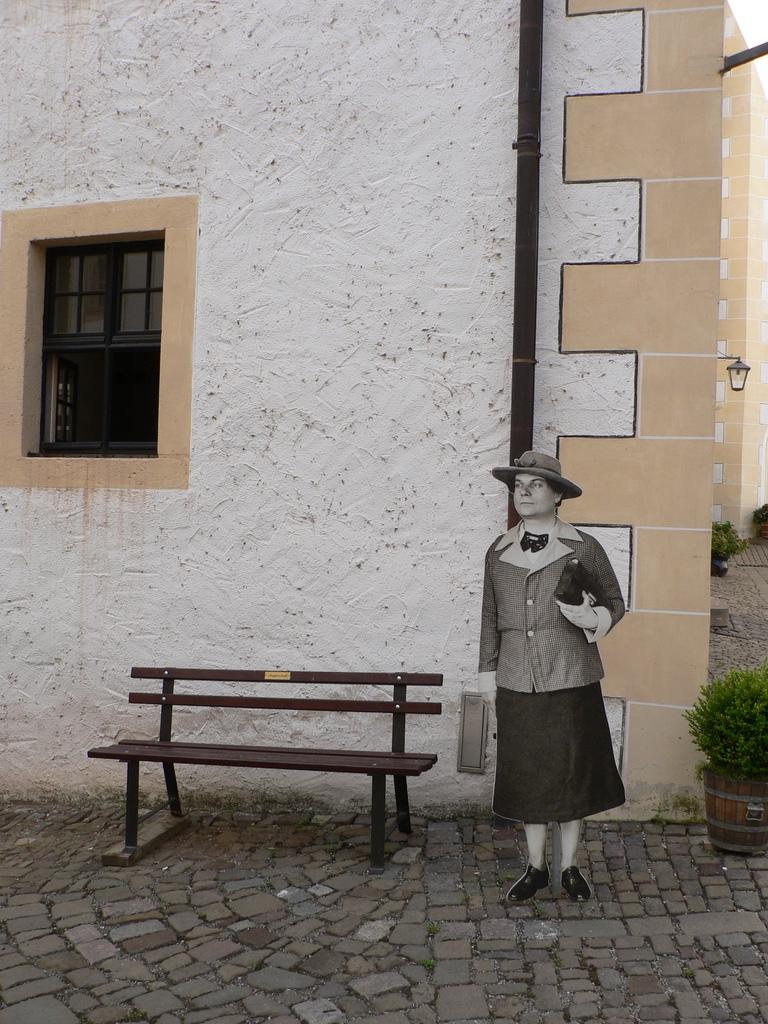Who is present in the image? There is a woman in the image. What is the woman holding in her hand? The woman is holding something in her hand, but the specific object is not mentioned in the facts. What type of headwear is the woman wearing? The woman is wearing a cap. What can be seen in the background of the image? There is a wall, a window, a bench, and plants in the background of the image. What type of key is the woman using to copy the achiever's work in the image? There is no mention of a key, copying, or an achiever in the image. The woman is simply holding something in her hand, and the specific object is not mentioned in the facts. 